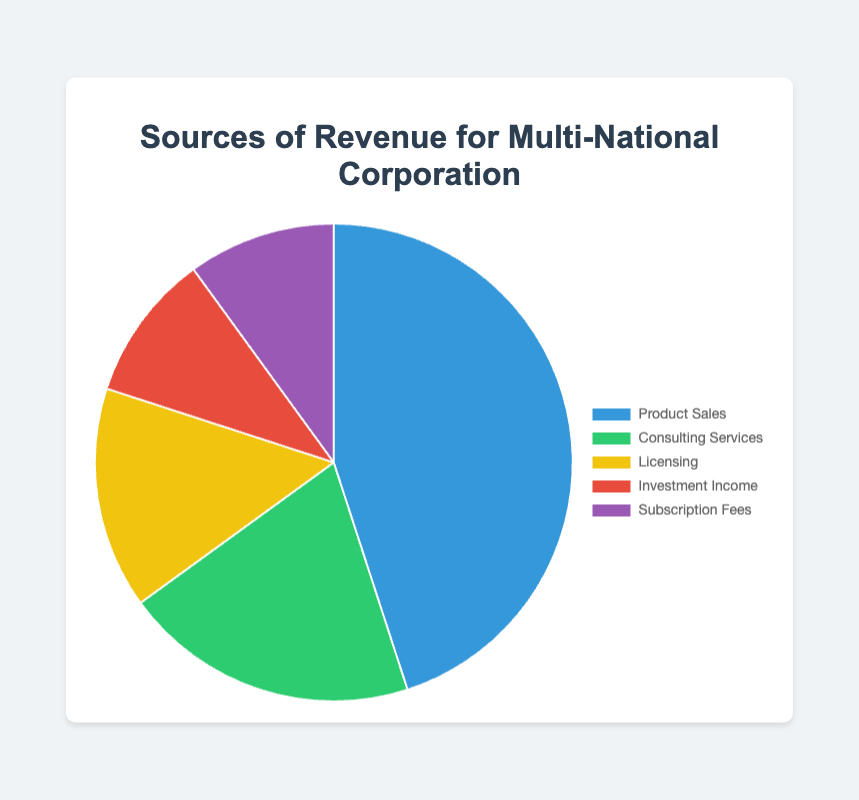Which source is the largest contributor to revenue? By looking at the pie chart, we can see that Product Sales has the largest segment, which means it is the largest contributor.
Answer: Product Sales What percentage of revenue comes from Subscription Fees and Investment Income combined? Subscription Fees contribute 10% and Investment Income also contributes 10%. Adding these two percentages: 10% + 10% = 20%.
Answer: 20% How much greater is the revenue percentage from Product Sales compared to Licensing? Product Sales contribute 45% and Licensing contributes 15%. The difference is: 45% - 15% = 30%.
Answer: 30% Which revenue source has the smallest contribution and what is its percentage? By looking at the pie chart, the smallest segment belongs to either Subscription Fees or Investment Income, both contributing 10%.
Answer: Subscription Fees or Investment Income (10%) What are the top two sources of revenue and their combined percentage? The top two sources of revenue are Product Sales (45%) and Consulting Services (20%). Their combined percentage is: 45% + 20% = 65%.
Answer: 65% What is the combined percentage of revenue for all sources except Product Sales? Excluding Product Sales (45%), the remaining sources are Consulting Services (20%), Licensing (15%), Investment Income (10%), and Subscription Fees (10%). Adding these: 20% + 15% + 10% + 10% = 55%.
Answer: 55% If the corporation increased its Licensing revenue by 5%, what would be the new percentage for Licensing? Currently, Licensing is 15%. An increase of 5% would result in: 15% + 5% = 20%.
Answer: 20% Which two revenue sources contribute equally to the overall revenue? By observing the pie chart, both Investment Income and Subscription Fees contribute equally at 10% each.
Answer: Investment Income and Subscription Fees What is the average percentage contribution from all revenue sources? Summing all percentages: 45% (Product Sales) + 20% (Consulting Services) + 15% (Licensing) + 10% (Investment Income) + 10% (Subscription Fees) = 100%. There are 5 sources, so the average is 100% / 5 = 20%.
Answer: 20% Which segment is represented by the color green and what is its percentage contribution? The pie chart shows that the segment represented by green is Consulting Services, contributing 20%.
Answer: Consulting Services (20%) 